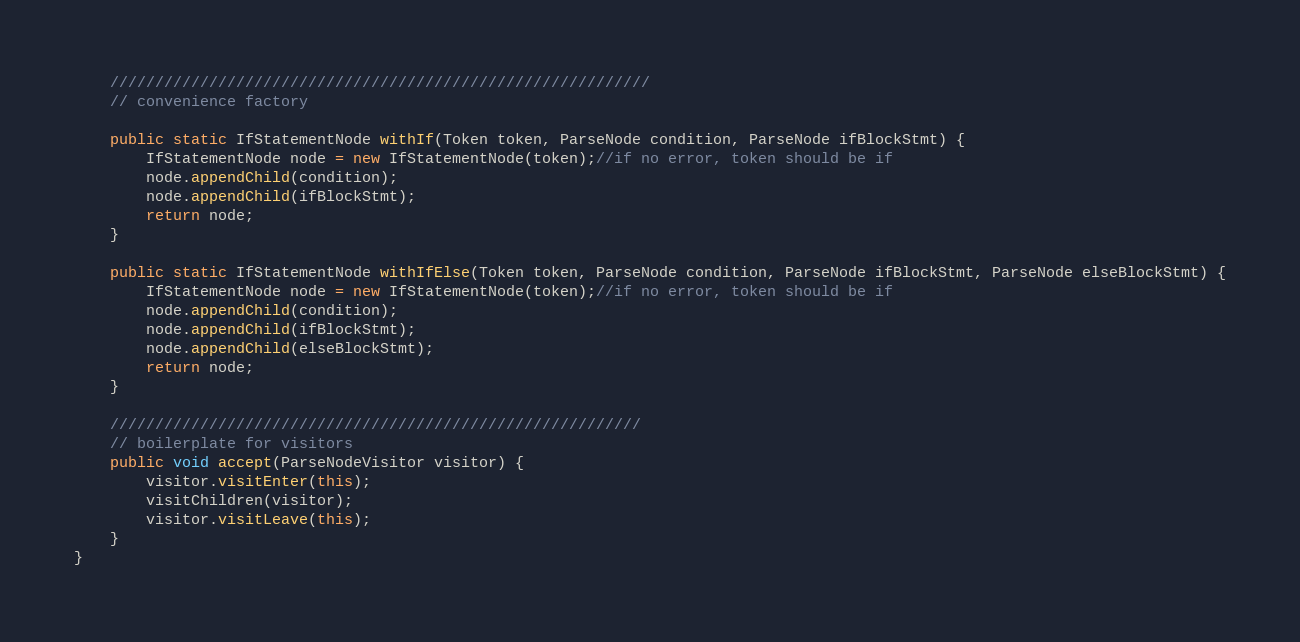<code> <loc_0><loc_0><loc_500><loc_500><_Java_>	////////////////////////////////////////////////////////////
	// convenience factory
	
	public static IfStatementNode withIf(Token token, ParseNode condition, ParseNode ifBlockStmt) {
		IfStatementNode node = new IfStatementNode(token);//if no error, token should be if
		node.appendChild(condition);
		node.appendChild(ifBlockStmt);
		return node;
	}
	
	public static IfStatementNode withIfElse(Token token, ParseNode condition, ParseNode ifBlockStmt, ParseNode elseBlockStmt) {
		IfStatementNode node = new IfStatementNode(token);//if no error, token should be if
		node.appendChild(condition);
		node.appendChild(ifBlockStmt);
		node.appendChild(elseBlockStmt);
		return node;
	}
	
	///////////////////////////////////////////////////////////
	// boilerplate for visitors
	public void accept(ParseNodeVisitor visitor) {
		visitor.visitEnter(this);
		visitChildren(visitor);
		visitor.visitLeave(this);
	}
}
</code> 